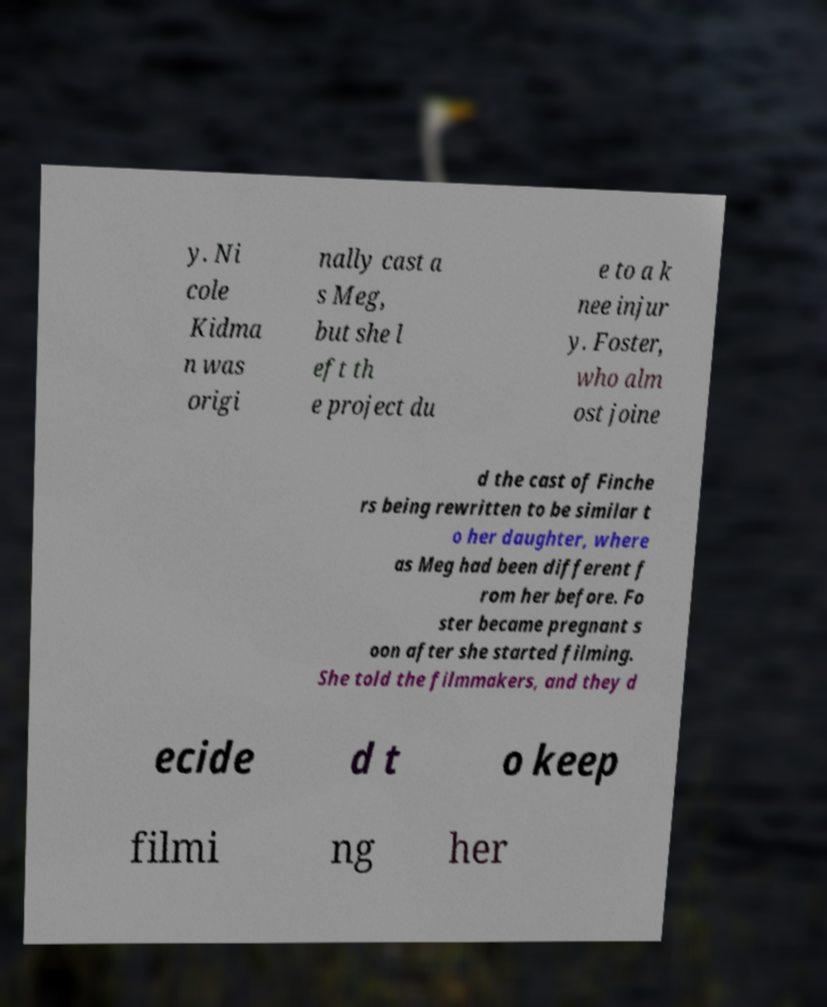Please read and relay the text visible in this image. What does it say? y. Ni cole Kidma n was origi nally cast a s Meg, but she l eft th e project du e to a k nee injur y. Foster, who alm ost joine d the cast of Finche rs being rewritten to be similar t o her daughter, where as Meg had been different f rom her before. Fo ster became pregnant s oon after she started filming. She told the filmmakers, and they d ecide d t o keep filmi ng her 